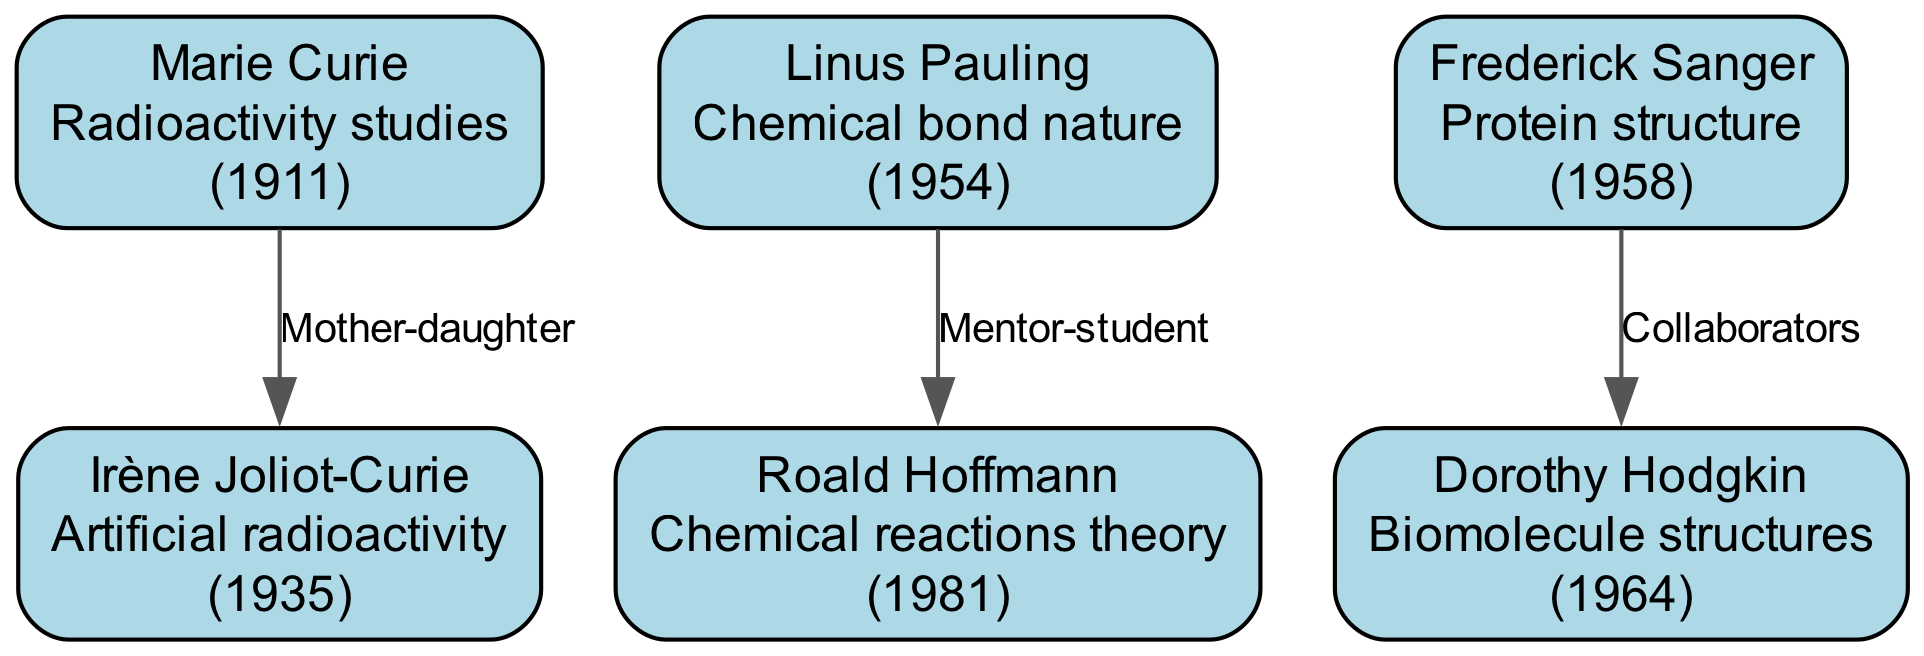What is the contribution of Marie Curie? The diagram shows Marie Curie's contribution as "Radioactivity studies." This information is presented directly in the box corresponding to her node.
Answer: Radioactivity studies Who is the mother of Irène Joliot-Curie? The edge connecting Marie Curie to Irène Joliot-Curie indicates that Marie Curie is Irène's mother. This relationship is explicitly labeled as "Mother-daughter" in the diagram.
Answer: Marie Curie How many nodes are in the diagram? Counting the number of unique individuals represented in the diagram, I note the presence of six distinct nodes: Marie Curie, Irène Joliot-Curie, Linus Pauling, Frederick Sanger, Dorothy Hodgkin, and Roald Hoffmann.
Answer: 6 What is the relationship between Frederick Sanger and Dorothy Hodgkin? The diagram shows a collaborative relationship represented by an edge connecting Frederick Sanger and Dorothy Hodgkin, with the description "Collaborators." This indicates they worked together in their scientific endeavors.
Answer: Collaborators Who mentored Roald Hoffmann? The relationship line from Linus Pauling to Roald Hoffmann indicates that Linus Pauling was Roald Hoffmann’s mentor. It is explicitly labeled as "Mentor-student," clarifying this relationship further.
Answer: Linus Pauling In what year did Dorothy Hodgkin win the Nobel Prize? The diagram lists Dorothy Hodgkin's Nobel Prize year as 1964, which is clearly stated next to her name in her node.
Answer: 1964 How many relationships are depicted in the diagram? Examining the edges connecting the nodes, there are three distinct relationships noted: "Mother-daughter," "Mentor-student," and "Collaborators." This total represents all interactions shown between the individuals on the diagram.
Answer: 3 What does the contribution of Roald Hoffmann focus on? The node for Roald Hoffmann specifies his contribution as "Chemical reactions theory," which provides a clear description of his scientific focus within the diagram's context.
Answer: Chemical reactions theory Who are the collaborators in the diagram? The diagram specifically illustrates a collaborative relationship between Frederick Sanger and Dorothy Hodgkin, as indicated by the labeled edge "Collaborators." This is the only collaboration shown in the provided family tree.
Answer: Frederick Sanger and Dorothy Hodgkin 